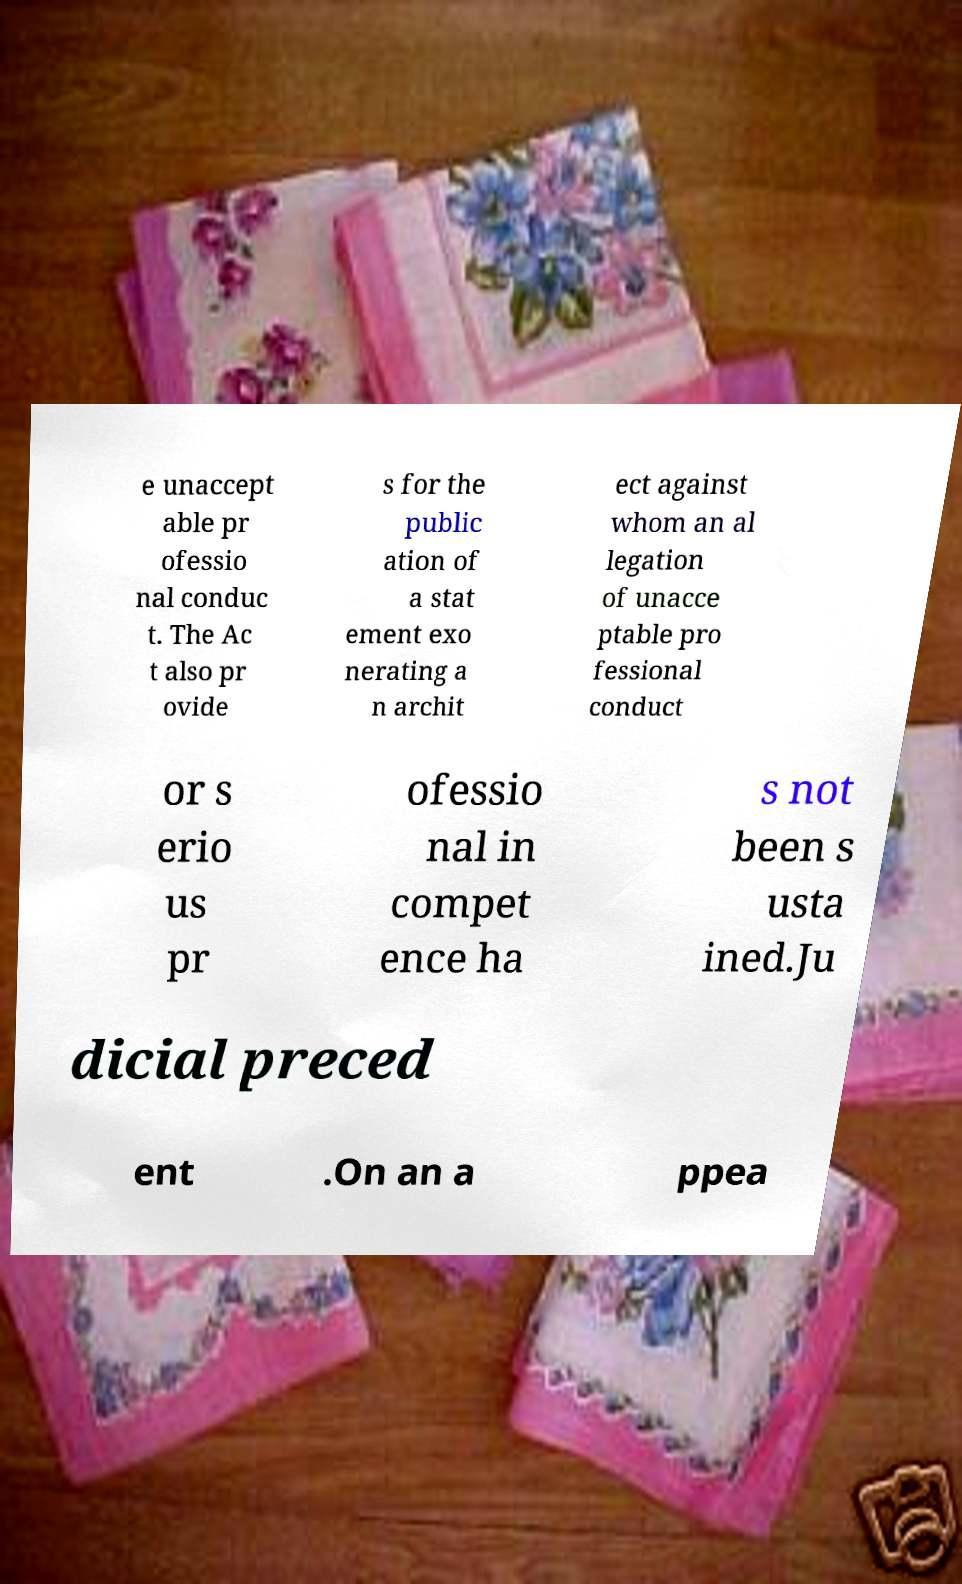I need the written content from this picture converted into text. Can you do that? e unaccept able pr ofessio nal conduc t. The Ac t also pr ovide s for the public ation of a stat ement exo nerating a n archit ect against whom an al legation of unacce ptable pro fessional conduct or s erio us pr ofessio nal in compet ence ha s not been s usta ined.Ju dicial preced ent .On an a ppea 